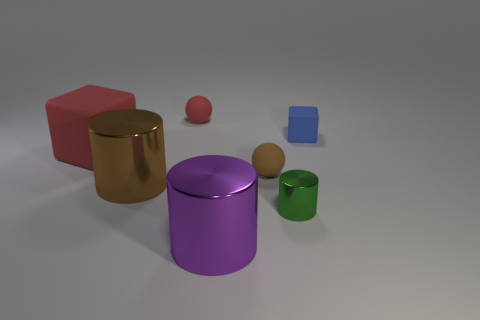Add 3 large green objects. How many objects exist? 10 Subtract all cylinders. How many objects are left? 4 Add 5 brown rubber balls. How many brown rubber balls exist? 6 Subtract 0 gray cubes. How many objects are left? 7 Subtract all small metallic balls. Subtract all metallic cylinders. How many objects are left? 4 Add 6 tiny brown matte things. How many tiny brown matte things are left? 7 